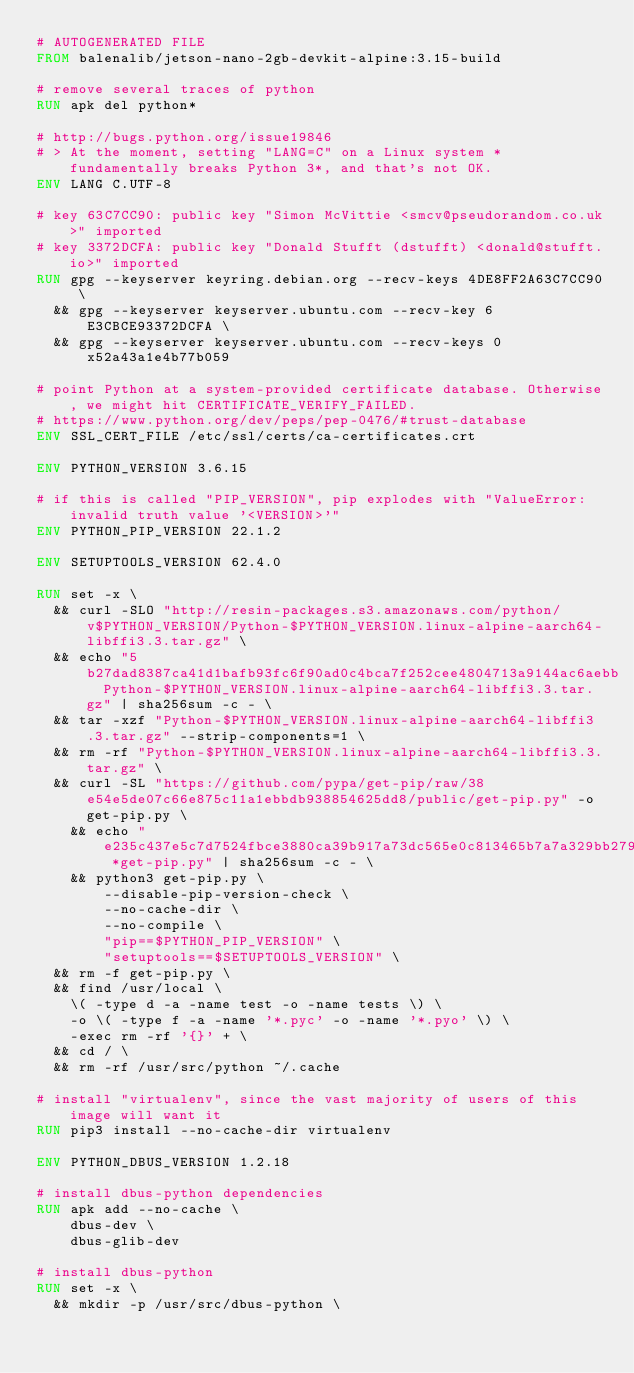Convert code to text. <code><loc_0><loc_0><loc_500><loc_500><_Dockerfile_># AUTOGENERATED FILE
FROM balenalib/jetson-nano-2gb-devkit-alpine:3.15-build

# remove several traces of python
RUN apk del python*

# http://bugs.python.org/issue19846
# > At the moment, setting "LANG=C" on a Linux system *fundamentally breaks Python 3*, and that's not OK.
ENV LANG C.UTF-8

# key 63C7CC90: public key "Simon McVittie <smcv@pseudorandom.co.uk>" imported
# key 3372DCFA: public key "Donald Stufft (dstufft) <donald@stufft.io>" imported
RUN gpg --keyserver keyring.debian.org --recv-keys 4DE8FF2A63C7CC90 \
	&& gpg --keyserver keyserver.ubuntu.com --recv-key 6E3CBCE93372DCFA \
	&& gpg --keyserver keyserver.ubuntu.com --recv-keys 0x52a43a1e4b77b059

# point Python at a system-provided certificate database. Otherwise, we might hit CERTIFICATE_VERIFY_FAILED.
# https://www.python.org/dev/peps/pep-0476/#trust-database
ENV SSL_CERT_FILE /etc/ssl/certs/ca-certificates.crt

ENV PYTHON_VERSION 3.6.15

# if this is called "PIP_VERSION", pip explodes with "ValueError: invalid truth value '<VERSION>'"
ENV PYTHON_PIP_VERSION 22.1.2

ENV SETUPTOOLS_VERSION 62.4.0

RUN set -x \
	&& curl -SLO "http://resin-packages.s3.amazonaws.com/python/v$PYTHON_VERSION/Python-$PYTHON_VERSION.linux-alpine-aarch64-libffi3.3.tar.gz" \
	&& echo "5b27dad8387ca41d1bafb93fc6f90ad0c4bca7f252cee4804713a9144ac6aebb  Python-$PYTHON_VERSION.linux-alpine-aarch64-libffi3.3.tar.gz" | sha256sum -c - \
	&& tar -xzf "Python-$PYTHON_VERSION.linux-alpine-aarch64-libffi3.3.tar.gz" --strip-components=1 \
	&& rm -rf "Python-$PYTHON_VERSION.linux-alpine-aarch64-libffi3.3.tar.gz" \
	&& curl -SL "https://github.com/pypa/get-pip/raw/38e54e5de07c66e875c11a1ebbdb938854625dd8/public/get-pip.py" -o get-pip.py \
    && echo "e235c437e5c7d7524fbce3880ca39b917a73dc565e0c813465b7a7a329bb279a *get-pip.py" | sha256sum -c - \
    && python3 get-pip.py \
        --disable-pip-version-check \
        --no-cache-dir \
        --no-compile \
        "pip==$PYTHON_PIP_VERSION" \
        "setuptools==$SETUPTOOLS_VERSION" \
	&& rm -f get-pip.py \
	&& find /usr/local \
		\( -type d -a -name test -o -name tests \) \
		-o \( -type f -a -name '*.pyc' -o -name '*.pyo' \) \
		-exec rm -rf '{}' + \
	&& cd / \
	&& rm -rf /usr/src/python ~/.cache

# install "virtualenv", since the vast majority of users of this image will want it
RUN pip3 install --no-cache-dir virtualenv

ENV PYTHON_DBUS_VERSION 1.2.18

# install dbus-python dependencies 
RUN apk add --no-cache \
		dbus-dev \
		dbus-glib-dev

# install dbus-python
RUN set -x \
	&& mkdir -p /usr/src/dbus-python \</code> 